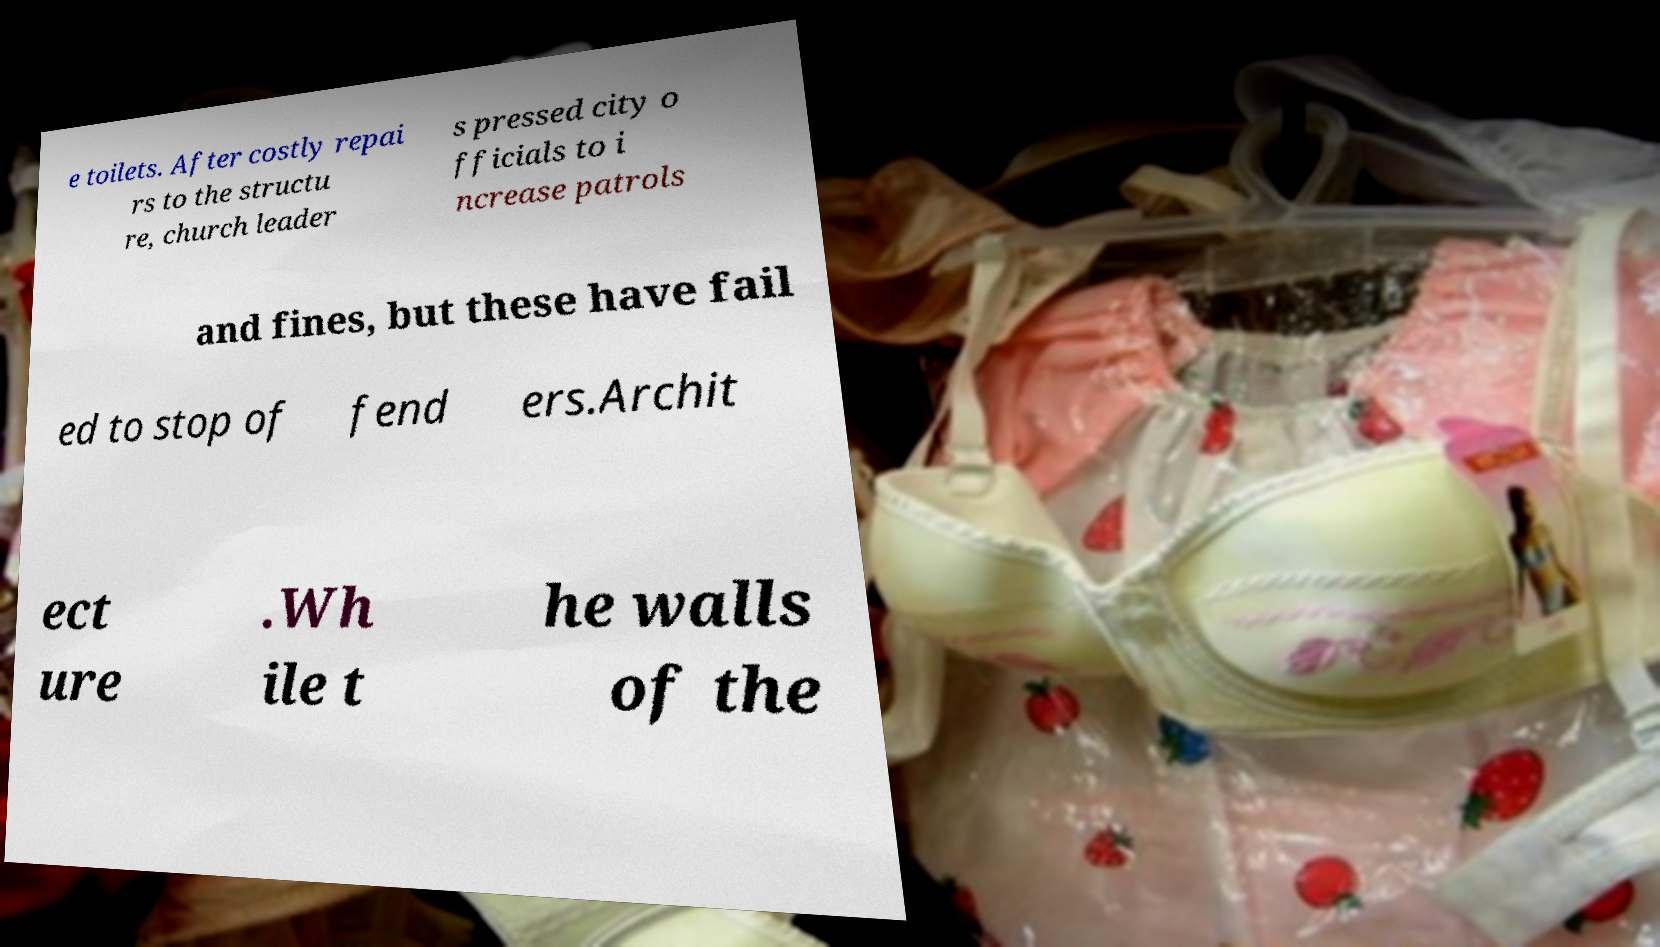Could you extract and type out the text from this image? e toilets. After costly repai rs to the structu re, church leader s pressed city o fficials to i ncrease patrols and fines, but these have fail ed to stop of fend ers.Archit ect ure .Wh ile t he walls of the 